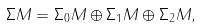<formula> <loc_0><loc_0><loc_500><loc_500>\Sigma M = \Sigma _ { 0 } M \oplus \Sigma _ { 1 } M \oplus \Sigma _ { 2 } M ,</formula> 